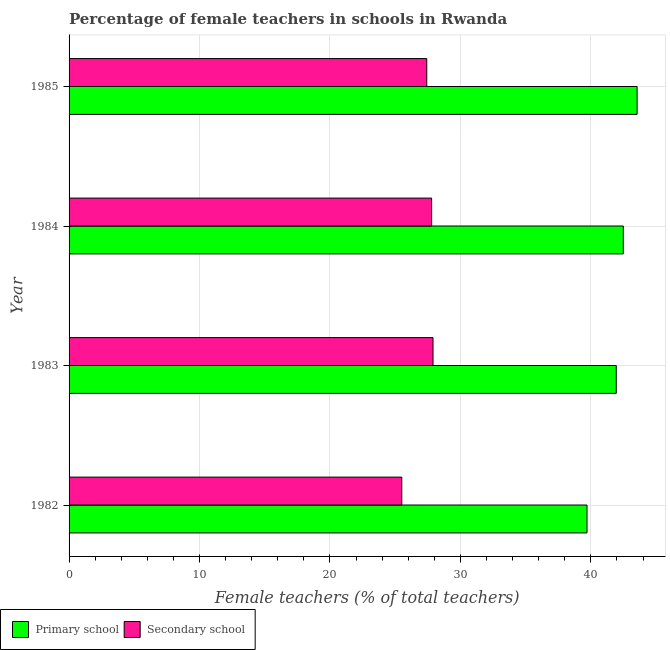How many groups of bars are there?
Provide a succinct answer. 4. Are the number of bars per tick equal to the number of legend labels?
Offer a terse response. Yes. In how many cases, is the number of bars for a given year not equal to the number of legend labels?
Provide a short and direct response. 0. What is the percentage of female teachers in secondary schools in 1984?
Provide a short and direct response. 27.79. Across all years, what is the maximum percentage of female teachers in primary schools?
Give a very brief answer. 43.55. Across all years, what is the minimum percentage of female teachers in secondary schools?
Make the answer very short. 25.51. In which year was the percentage of female teachers in primary schools maximum?
Make the answer very short. 1985. In which year was the percentage of female teachers in primary schools minimum?
Provide a succinct answer. 1982. What is the total percentage of female teachers in primary schools in the graph?
Give a very brief answer. 167.69. What is the difference between the percentage of female teachers in primary schools in 1982 and that in 1983?
Offer a very short reply. -2.24. What is the difference between the percentage of female teachers in primary schools in 1984 and the percentage of female teachers in secondary schools in 1985?
Ensure brevity in your answer.  15.07. What is the average percentage of female teachers in primary schools per year?
Give a very brief answer. 41.92. In the year 1985, what is the difference between the percentage of female teachers in secondary schools and percentage of female teachers in primary schools?
Provide a succinct answer. -16.12. In how many years, is the percentage of female teachers in primary schools greater than 22 %?
Your answer should be compact. 4. What is the ratio of the percentage of female teachers in secondary schools in 1984 to that in 1985?
Offer a terse response. 1.01. What is the difference between the highest and the second highest percentage of female teachers in secondary schools?
Your answer should be very brief. 0.11. What is the difference between the highest and the lowest percentage of female teachers in primary schools?
Provide a short and direct response. 3.84. In how many years, is the percentage of female teachers in primary schools greater than the average percentage of female teachers in primary schools taken over all years?
Offer a very short reply. 3. What does the 1st bar from the top in 1983 represents?
Provide a short and direct response. Secondary school. What does the 2nd bar from the bottom in 1982 represents?
Your response must be concise. Secondary school. Are all the bars in the graph horizontal?
Keep it short and to the point. Yes. How many years are there in the graph?
Provide a short and direct response. 4. Does the graph contain any zero values?
Keep it short and to the point. No. Does the graph contain grids?
Offer a terse response. Yes. What is the title of the graph?
Your answer should be compact. Percentage of female teachers in schools in Rwanda. What is the label or title of the X-axis?
Provide a short and direct response. Female teachers (% of total teachers). What is the label or title of the Y-axis?
Your answer should be compact. Year. What is the Female teachers (% of total teachers) of Primary school in 1982?
Your answer should be compact. 39.71. What is the Female teachers (% of total teachers) in Secondary school in 1982?
Make the answer very short. 25.51. What is the Female teachers (% of total teachers) of Primary school in 1983?
Provide a short and direct response. 41.95. What is the Female teachers (% of total teachers) of Secondary school in 1983?
Provide a short and direct response. 27.9. What is the Female teachers (% of total teachers) in Primary school in 1984?
Keep it short and to the point. 42.49. What is the Female teachers (% of total teachers) of Secondary school in 1984?
Make the answer very short. 27.79. What is the Female teachers (% of total teachers) of Primary school in 1985?
Offer a very short reply. 43.55. What is the Female teachers (% of total teachers) in Secondary school in 1985?
Your answer should be compact. 27.42. Across all years, what is the maximum Female teachers (% of total teachers) of Primary school?
Offer a very short reply. 43.55. Across all years, what is the maximum Female teachers (% of total teachers) of Secondary school?
Your answer should be compact. 27.9. Across all years, what is the minimum Female teachers (% of total teachers) of Primary school?
Your response must be concise. 39.71. Across all years, what is the minimum Female teachers (% of total teachers) in Secondary school?
Your answer should be very brief. 25.51. What is the total Female teachers (% of total teachers) of Primary school in the graph?
Offer a terse response. 167.69. What is the total Female teachers (% of total teachers) of Secondary school in the graph?
Ensure brevity in your answer.  108.62. What is the difference between the Female teachers (% of total teachers) of Primary school in 1982 and that in 1983?
Make the answer very short. -2.24. What is the difference between the Female teachers (% of total teachers) in Secondary school in 1982 and that in 1983?
Offer a terse response. -2.4. What is the difference between the Female teachers (% of total teachers) of Primary school in 1982 and that in 1984?
Make the answer very short. -2.78. What is the difference between the Female teachers (% of total teachers) of Secondary school in 1982 and that in 1984?
Ensure brevity in your answer.  -2.29. What is the difference between the Female teachers (% of total teachers) in Primary school in 1982 and that in 1985?
Provide a succinct answer. -3.84. What is the difference between the Female teachers (% of total teachers) of Secondary school in 1982 and that in 1985?
Your response must be concise. -1.92. What is the difference between the Female teachers (% of total teachers) in Primary school in 1983 and that in 1984?
Offer a very short reply. -0.54. What is the difference between the Female teachers (% of total teachers) of Secondary school in 1983 and that in 1984?
Offer a very short reply. 0.11. What is the difference between the Female teachers (% of total teachers) in Primary school in 1983 and that in 1985?
Your answer should be compact. -1.6. What is the difference between the Female teachers (% of total teachers) in Secondary school in 1983 and that in 1985?
Your answer should be very brief. 0.48. What is the difference between the Female teachers (% of total teachers) of Primary school in 1984 and that in 1985?
Ensure brevity in your answer.  -1.06. What is the difference between the Female teachers (% of total teachers) in Secondary school in 1984 and that in 1985?
Make the answer very short. 0.37. What is the difference between the Female teachers (% of total teachers) in Primary school in 1982 and the Female teachers (% of total teachers) in Secondary school in 1983?
Offer a very short reply. 11.81. What is the difference between the Female teachers (% of total teachers) of Primary school in 1982 and the Female teachers (% of total teachers) of Secondary school in 1984?
Your response must be concise. 11.91. What is the difference between the Female teachers (% of total teachers) in Primary school in 1982 and the Female teachers (% of total teachers) in Secondary school in 1985?
Your answer should be very brief. 12.28. What is the difference between the Female teachers (% of total teachers) in Primary school in 1983 and the Female teachers (% of total teachers) in Secondary school in 1984?
Offer a terse response. 14.16. What is the difference between the Female teachers (% of total teachers) of Primary school in 1983 and the Female teachers (% of total teachers) of Secondary school in 1985?
Ensure brevity in your answer.  14.53. What is the difference between the Female teachers (% of total teachers) of Primary school in 1984 and the Female teachers (% of total teachers) of Secondary school in 1985?
Make the answer very short. 15.07. What is the average Female teachers (% of total teachers) of Primary school per year?
Your response must be concise. 41.92. What is the average Female teachers (% of total teachers) in Secondary school per year?
Your answer should be very brief. 27.16. In the year 1982, what is the difference between the Female teachers (% of total teachers) of Primary school and Female teachers (% of total teachers) of Secondary school?
Provide a succinct answer. 14.2. In the year 1983, what is the difference between the Female teachers (% of total teachers) of Primary school and Female teachers (% of total teachers) of Secondary school?
Offer a terse response. 14.05. In the year 1984, what is the difference between the Female teachers (% of total teachers) in Primary school and Female teachers (% of total teachers) in Secondary school?
Provide a short and direct response. 14.69. In the year 1985, what is the difference between the Female teachers (% of total teachers) of Primary school and Female teachers (% of total teachers) of Secondary school?
Keep it short and to the point. 16.12. What is the ratio of the Female teachers (% of total teachers) of Primary school in 1982 to that in 1983?
Provide a short and direct response. 0.95. What is the ratio of the Female teachers (% of total teachers) of Secondary school in 1982 to that in 1983?
Give a very brief answer. 0.91. What is the ratio of the Female teachers (% of total teachers) in Primary school in 1982 to that in 1984?
Make the answer very short. 0.93. What is the ratio of the Female teachers (% of total teachers) of Secondary school in 1982 to that in 1984?
Offer a very short reply. 0.92. What is the ratio of the Female teachers (% of total teachers) in Primary school in 1982 to that in 1985?
Provide a succinct answer. 0.91. What is the ratio of the Female teachers (% of total teachers) in Secondary school in 1982 to that in 1985?
Your answer should be very brief. 0.93. What is the ratio of the Female teachers (% of total teachers) of Primary school in 1983 to that in 1984?
Make the answer very short. 0.99. What is the ratio of the Female teachers (% of total teachers) of Primary school in 1983 to that in 1985?
Ensure brevity in your answer.  0.96. What is the ratio of the Female teachers (% of total teachers) of Secondary school in 1983 to that in 1985?
Keep it short and to the point. 1.02. What is the ratio of the Female teachers (% of total teachers) of Primary school in 1984 to that in 1985?
Offer a very short reply. 0.98. What is the ratio of the Female teachers (% of total teachers) of Secondary school in 1984 to that in 1985?
Ensure brevity in your answer.  1.01. What is the difference between the highest and the second highest Female teachers (% of total teachers) in Primary school?
Provide a succinct answer. 1.06. What is the difference between the highest and the second highest Female teachers (% of total teachers) of Secondary school?
Your answer should be very brief. 0.11. What is the difference between the highest and the lowest Female teachers (% of total teachers) of Primary school?
Keep it short and to the point. 3.84. What is the difference between the highest and the lowest Female teachers (% of total teachers) in Secondary school?
Your answer should be compact. 2.4. 